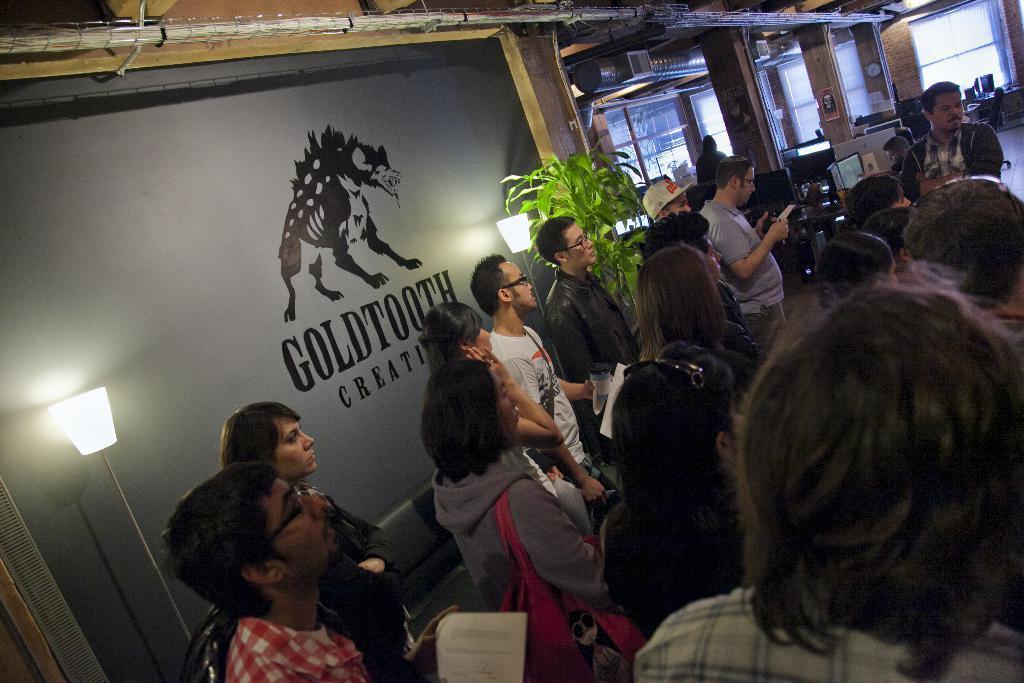Can you describe this image briefly? In this picture we can see some people standing in the front, on the left side there are two lamps and a plant, in the background we can see pillars, screens, tables and chairs, on the left side there is a wall, we can see some text on the wall, we can also see a glass in the background. 